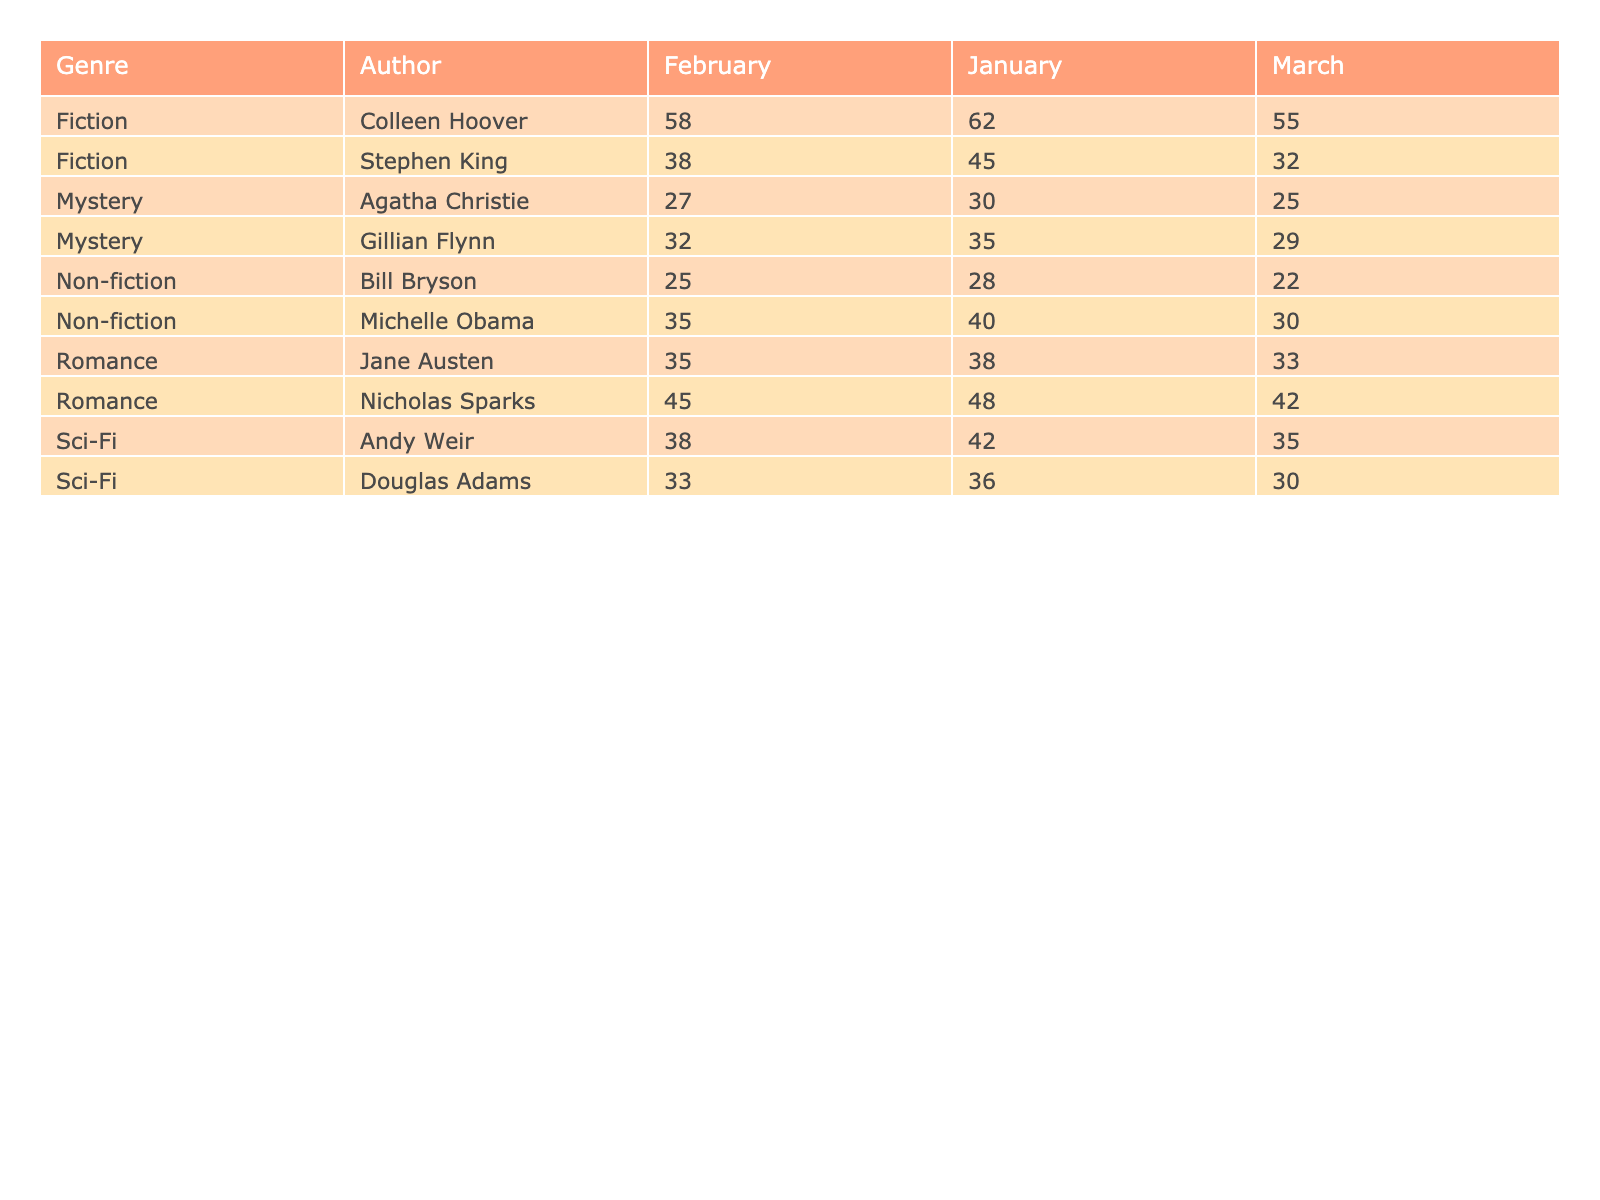What were the total sales for Fiction books in February? To find the total sales for Fiction books in February, we need to look at the sales figures for each author in that genre. The figures are: Stephen King (38) and Colleen Hoover (58). Adding these together gives us 38 + 58 = 96.
Answer: 96 Which author had the highest sales in January? In January, we compare the sales of each author across all genres. For Fiction, Stephen King had 45 and Colleen Hoover had 62; for Non-fiction, Michelle Obama had 40 and Bill Bryson had 28; for Mystery, Agatha Christie had 30 and Gillian Flynn had 35; for Romance, Nicholas Sparks had 48 and Jane Austen had 38; and for Sci-Fi, Andy Weir had 42 and Douglas Adams had 36. Among these, Colleen Hoover's sales of 62 were the highest.
Answer: Colleen Hoover Did Agatha Christie sell more books than Gillian Flynn in February? To compare sales for February, Agatha Christie sold 27 copies, and Gillian Flynn sold 32 copies. Since 27 is less than 32, Agatha Christie did not sell more books than Gillian Flynn.
Answer: No What is the average number of sales for Sci-Fi books across the three months? For Sci-Fi books, the sales are: Andy Weir (42 + 38 + 35 = 115) and Douglas Adams (36 + 33 + 30 = 99). Summing these gives total Sci-Fi sales of 115 + 99 = 214 across the three months, and since there are 2 authors, the average will be 214/6 = 35.67.
Answer: 35.67 Which genre had the highest total sales overall? We need to calculate the total sales for each genre: Fiction total is (45 + 38 + 32 + 62 + 58 + 55) = 290; Non-fiction total is (40 + 35 + 30 + 28 + 25 + 22) = 180; Mystery total is (30 + 27 + 25 + 35 + 32 + 29) = 208; Romance total is (48 + 45 + 42 + 38 + 35 + 33) = 241; and Sci-Fi total is (42 + 38 + 35 + 36 + 33 + 30) = 214. Fiction has the highest total at 290.
Answer: Fiction 